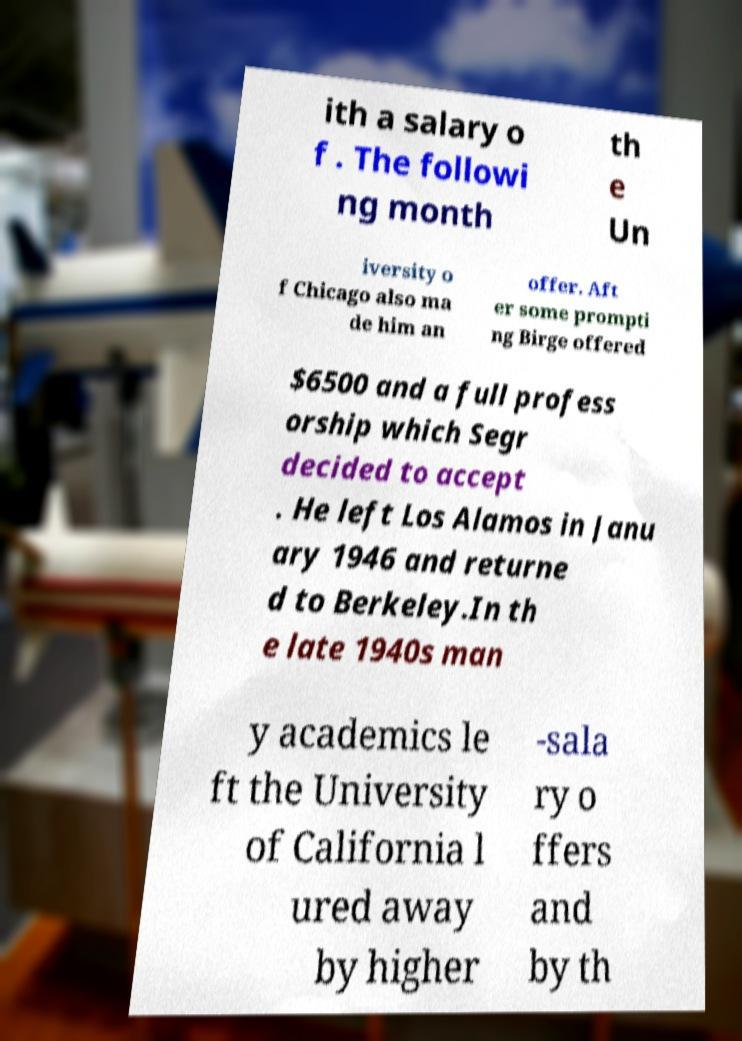Could you extract and type out the text from this image? ith a salary o f . The followi ng month th e Un iversity o f Chicago also ma de him an offer. Aft er some prompti ng Birge offered $6500 and a full profess orship which Segr decided to accept . He left Los Alamos in Janu ary 1946 and returne d to Berkeley.In th e late 1940s man y academics le ft the University of California l ured away by higher -sala ry o ffers and by th 